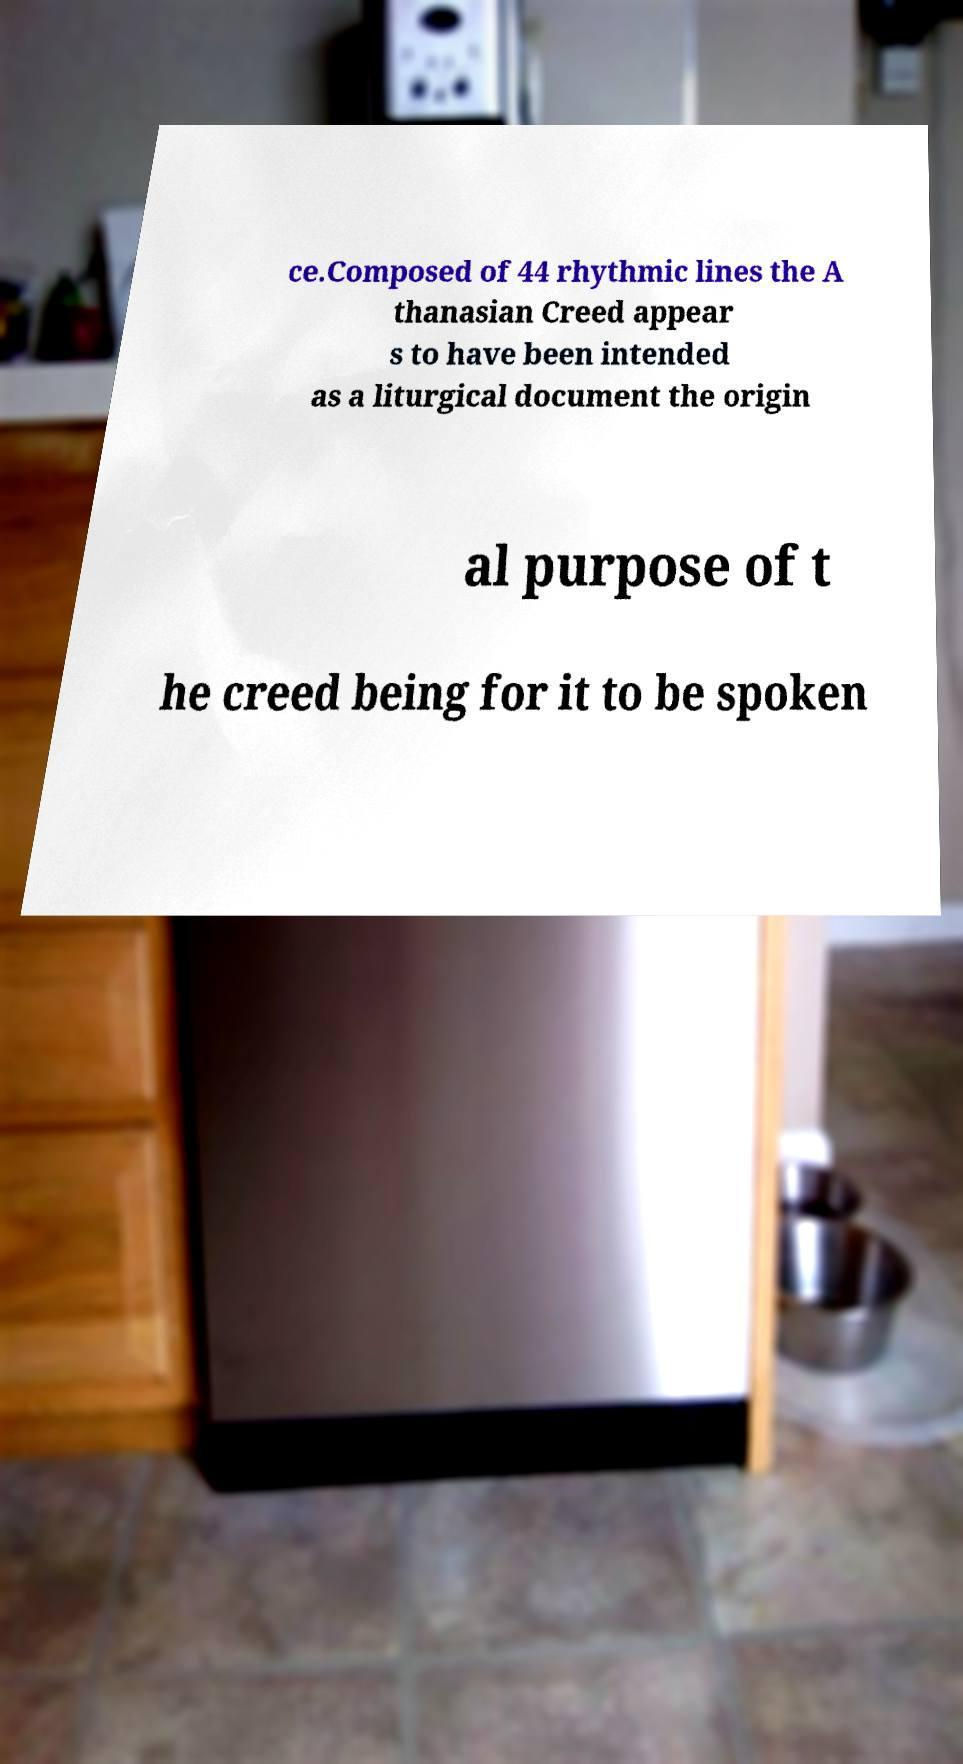There's text embedded in this image that I need extracted. Can you transcribe it verbatim? ce.Composed of 44 rhythmic lines the A thanasian Creed appear s to have been intended as a liturgical document the origin al purpose of t he creed being for it to be spoken 